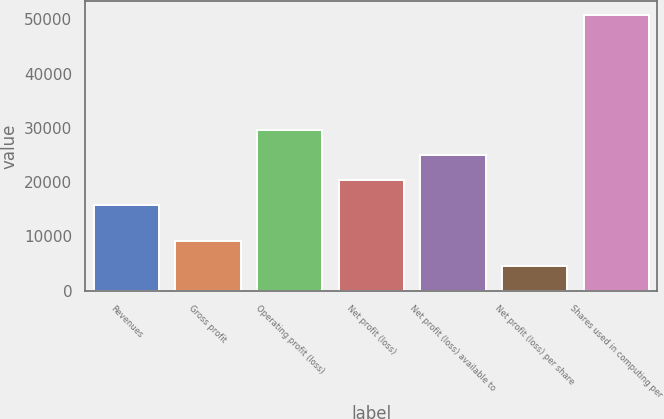<chart> <loc_0><loc_0><loc_500><loc_500><bar_chart><fcel>Revenues<fcel>Gross profit<fcel>Operating profit (loss)<fcel>Net profit (loss)<fcel>Net profit (loss) available to<fcel>Net profit (loss) per share<fcel>Shares used in computing per<nl><fcel>15858<fcel>9230.74<fcel>29703.5<fcel>20473.2<fcel>25088.3<fcel>4615.58<fcel>50767.2<nl></chart> 